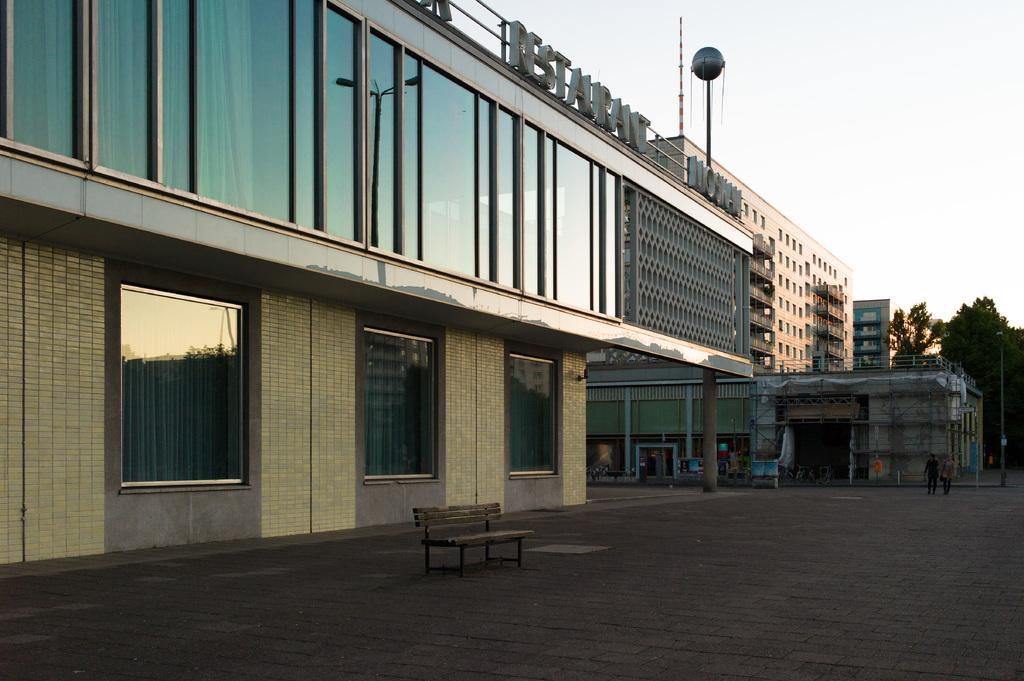Describe this image in one or two sentences. In the picture we can see the buildings and glasses in it and beside it, we can see some trees and in the background we can see a sky. 